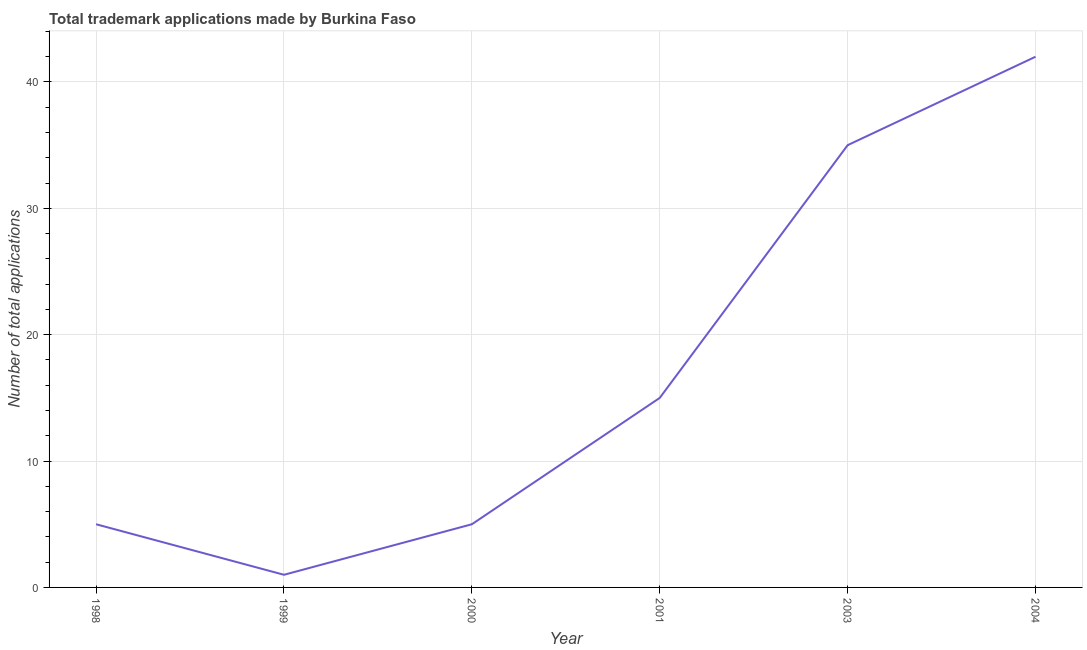What is the number of trademark applications in 2003?
Provide a succinct answer. 35. Across all years, what is the maximum number of trademark applications?
Provide a short and direct response. 42. Across all years, what is the minimum number of trademark applications?
Your answer should be very brief. 1. In which year was the number of trademark applications maximum?
Your answer should be compact. 2004. What is the sum of the number of trademark applications?
Make the answer very short. 103. What is the average number of trademark applications per year?
Keep it short and to the point. 17.17. What is the median number of trademark applications?
Ensure brevity in your answer.  10. What is the ratio of the number of trademark applications in 2003 to that in 2004?
Offer a terse response. 0.83. Is the number of trademark applications in 1999 less than that in 2000?
Give a very brief answer. Yes. Is the difference between the number of trademark applications in 1999 and 2001 greater than the difference between any two years?
Provide a succinct answer. No. What is the difference between the highest and the second highest number of trademark applications?
Ensure brevity in your answer.  7. Is the sum of the number of trademark applications in 1999 and 2001 greater than the maximum number of trademark applications across all years?
Provide a succinct answer. No. What is the difference between the highest and the lowest number of trademark applications?
Ensure brevity in your answer.  41. In how many years, is the number of trademark applications greater than the average number of trademark applications taken over all years?
Provide a short and direct response. 2. Does the number of trademark applications monotonically increase over the years?
Provide a short and direct response. No. How many lines are there?
Give a very brief answer. 1. Does the graph contain grids?
Give a very brief answer. Yes. What is the title of the graph?
Your response must be concise. Total trademark applications made by Burkina Faso. What is the label or title of the X-axis?
Offer a terse response. Year. What is the label or title of the Y-axis?
Your answer should be very brief. Number of total applications. What is the Number of total applications of 1999?
Give a very brief answer. 1. What is the Number of total applications of 2000?
Give a very brief answer. 5. What is the Number of total applications of 2001?
Keep it short and to the point. 15. What is the difference between the Number of total applications in 1998 and 1999?
Give a very brief answer. 4. What is the difference between the Number of total applications in 1998 and 2000?
Provide a succinct answer. 0. What is the difference between the Number of total applications in 1998 and 2001?
Provide a short and direct response. -10. What is the difference between the Number of total applications in 1998 and 2004?
Offer a terse response. -37. What is the difference between the Number of total applications in 1999 and 2001?
Your answer should be very brief. -14. What is the difference between the Number of total applications in 1999 and 2003?
Give a very brief answer. -34. What is the difference between the Number of total applications in 1999 and 2004?
Make the answer very short. -41. What is the difference between the Number of total applications in 2000 and 2003?
Make the answer very short. -30. What is the difference between the Number of total applications in 2000 and 2004?
Your answer should be compact. -37. What is the difference between the Number of total applications in 2001 and 2004?
Make the answer very short. -27. What is the ratio of the Number of total applications in 1998 to that in 1999?
Your answer should be compact. 5. What is the ratio of the Number of total applications in 1998 to that in 2001?
Offer a terse response. 0.33. What is the ratio of the Number of total applications in 1998 to that in 2003?
Give a very brief answer. 0.14. What is the ratio of the Number of total applications in 1998 to that in 2004?
Your answer should be very brief. 0.12. What is the ratio of the Number of total applications in 1999 to that in 2001?
Ensure brevity in your answer.  0.07. What is the ratio of the Number of total applications in 1999 to that in 2003?
Your answer should be compact. 0.03. What is the ratio of the Number of total applications in 1999 to that in 2004?
Your answer should be very brief. 0.02. What is the ratio of the Number of total applications in 2000 to that in 2001?
Your response must be concise. 0.33. What is the ratio of the Number of total applications in 2000 to that in 2003?
Your answer should be very brief. 0.14. What is the ratio of the Number of total applications in 2000 to that in 2004?
Give a very brief answer. 0.12. What is the ratio of the Number of total applications in 2001 to that in 2003?
Provide a succinct answer. 0.43. What is the ratio of the Number of total applications in 2001 to that in 2004?
Ensure brevity in your answer.  0.36. What is the ratio of the Number of total applications in 2003 to that in 2004?
Give a very brief answer. 0.83. 